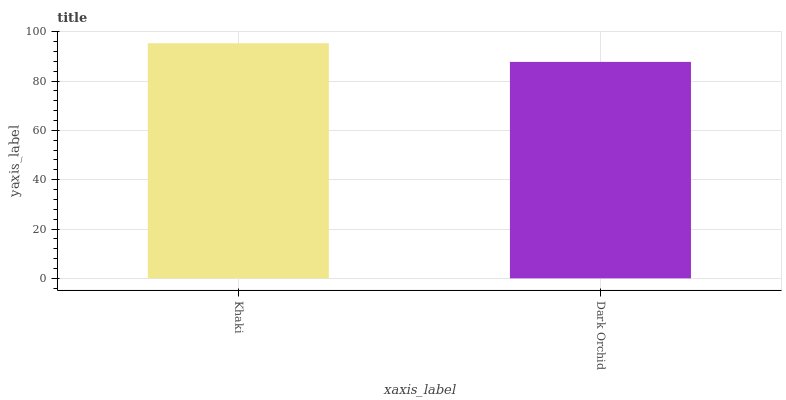Is Dark Orchid the minimum?
Answer yes or no. Yes. Is Khaki the maximum?
Answer yes or no. Yes. Is Dark Orchid the maximum?
Answer yes or no. No. Is Khaki greater than Dark Orchid?
Answer yes or no. Yes. Is Dark Orchid less than Khaki?
Answer yes or no. Yes. Is Dark Orchid greater than Khaki?
Answer yes or no. No. Is Khaki less than Dark Orchid?
Answer yes or no. No. Is Khaki the high median?
Answer yes or no. Yes. Is Dark Orchid the low median?
Answer yes or no. Yes. Is Dark Orchid the high median?
Answer yes or no. No. Is Khaki the low median?
Answer yes or no. No. 